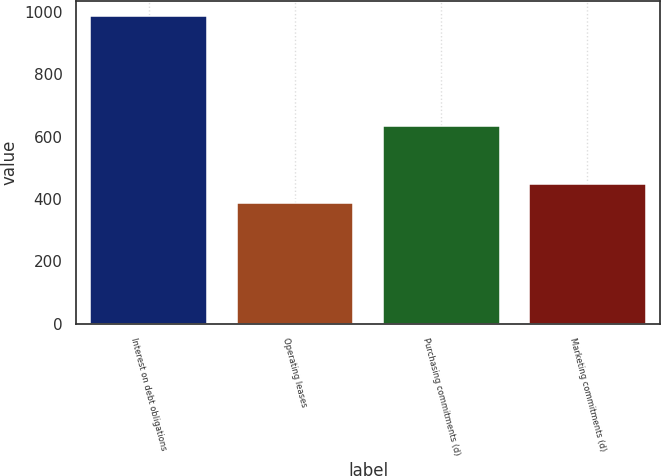Convert chart to OTSL. <chart><loc_0><loc_0><loc_500><loc_500><bar_chart><fcel>Interest on debt obligations<fcel>Operating leases<fcel>Purchasing commitments (d)<fcel>Marketing commitments (d)<nl><fcel>987<fcel>387<fcel>635<fcel>447<nl></chart> 